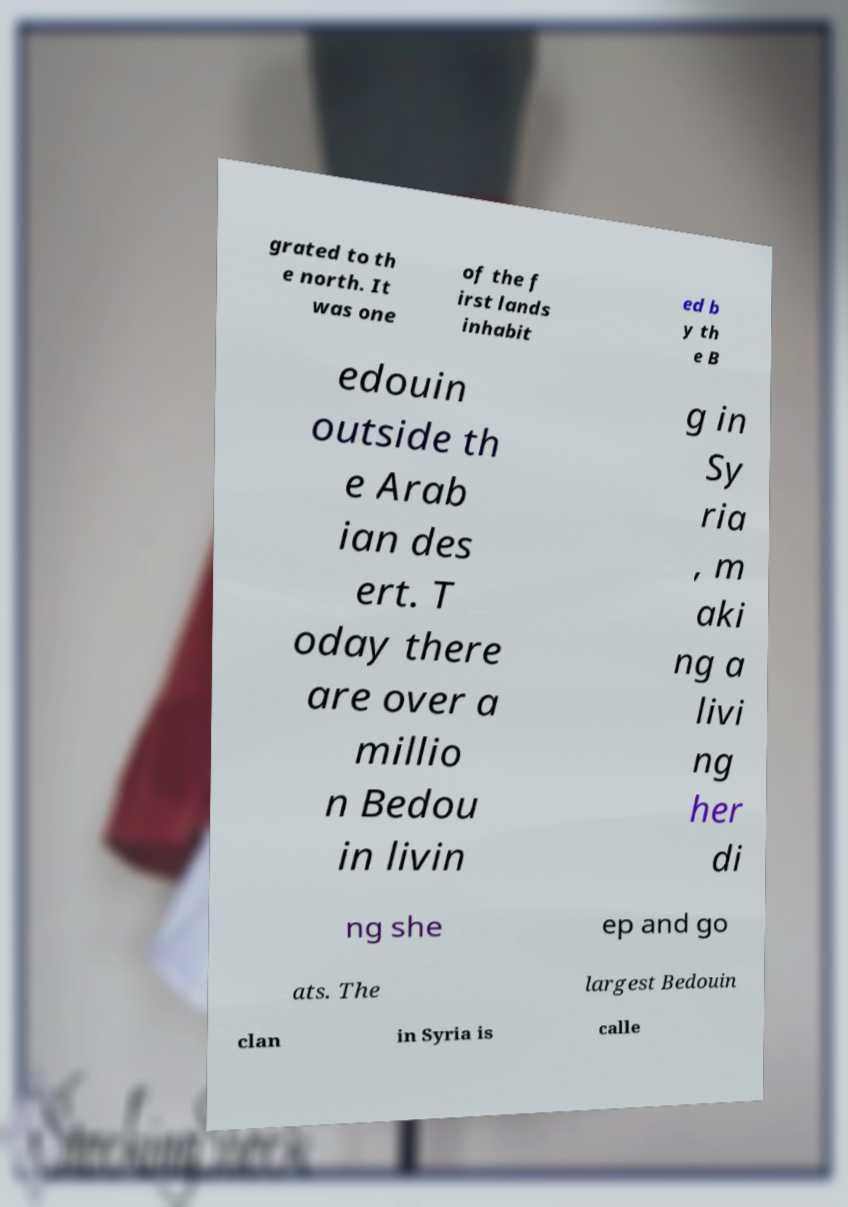Please identify and transcribe the text found in this image. grated to th e north. It was one of the f irst lands inhabit ed b y th e B edouin outside th e Arab ian des ert. T oday there are over a millio n Bedou in livin g in Sy ria , m aki ng a livi ng her di ng she ep and go ats. The largest Bedouin clan in Syria is calle 